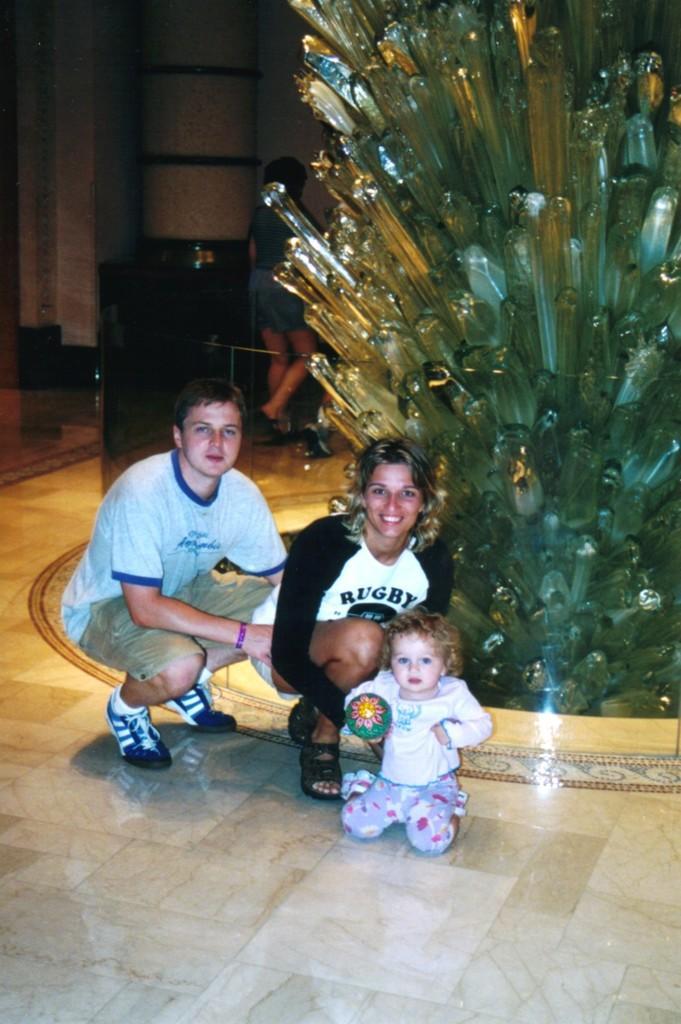Could you give a brief overview of what you see in this image? In this picture, we see a man and the women are in squad position. Beside them, we see a baby girl is holding a green color object in her hands. Behind them, we see an artificial tree. Behind that, we see the woman in blue dress is stunning. In the background, we see a white wall. 